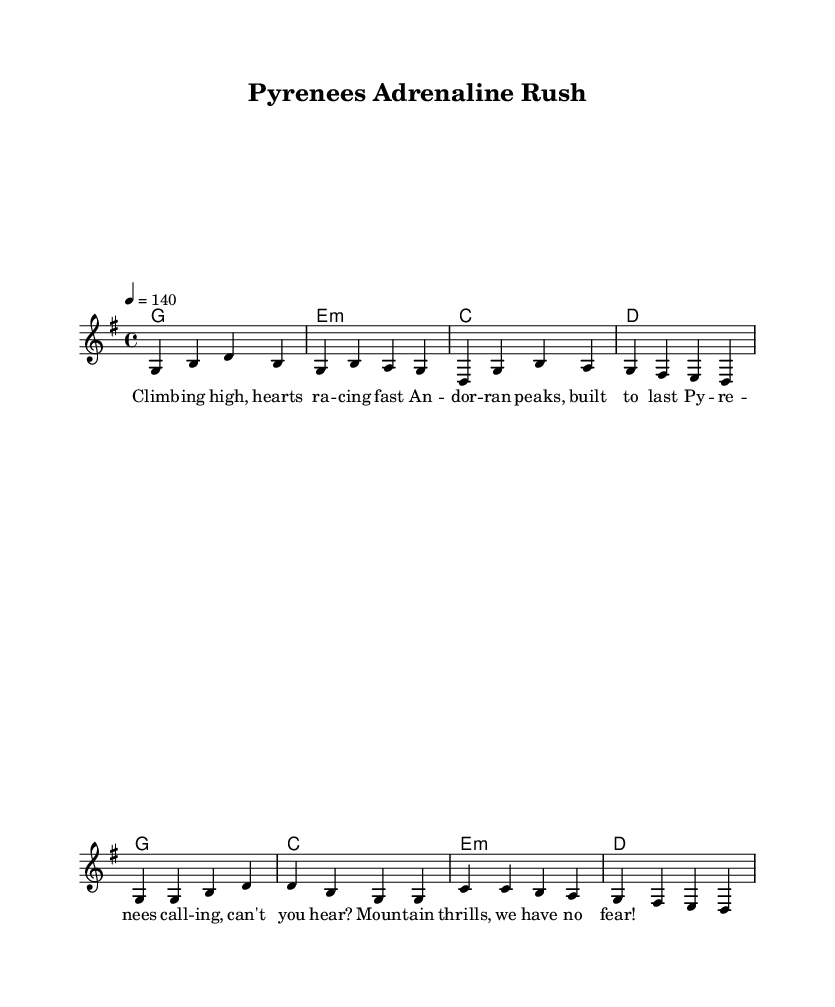What is the key signature of this music? The key signature of this piece is G major, which contains one sharp (F#). This can be confirmed by the initial key signature notation at the beginning of the score.
Answer: G major What is the time signature of this music? The time signature is 4/4, indicated at the start of the score. This means there are four beats in a measure and the quarter note gets one beat.
Answer: 4/4 What is the tempo of the piece? The tempo marking is indicated as 4 = 140, which means the music should be played at a pace of 140 beats per minute. This indicates a lively and energetic tempo typical for country rock music.
Answer: 140 What chords are used in the verse section? The chords in the verse section are G, E minor, C, and D, as listed in the chord mode above the melody for that section.
Answer: G, E minor, C, D How many measures are in the chorus section? The chorus section comprises four measures, as seen in the notation after the verse. Each measure is indicated by a vertical line, making it easy to count them.
Answer: 4 What is the general theme of the lyrics? The lyrics convey themes of adventure and excitement related to mountain sports in the Pyrenees, reflecting both the thrill and beauty of nature. This is evident through phrases like "Climbing high" and "Mountain thrills."
Answer: Adventure What element is uniquely characteristic of country rock in this piece? The upbeat tempo combined with the use of traditional chord progressions, as well as the thematic focus on outdoor activities and adventure, distinctly characterize this piece as country rock music.
Answer: Upbeat tempo 